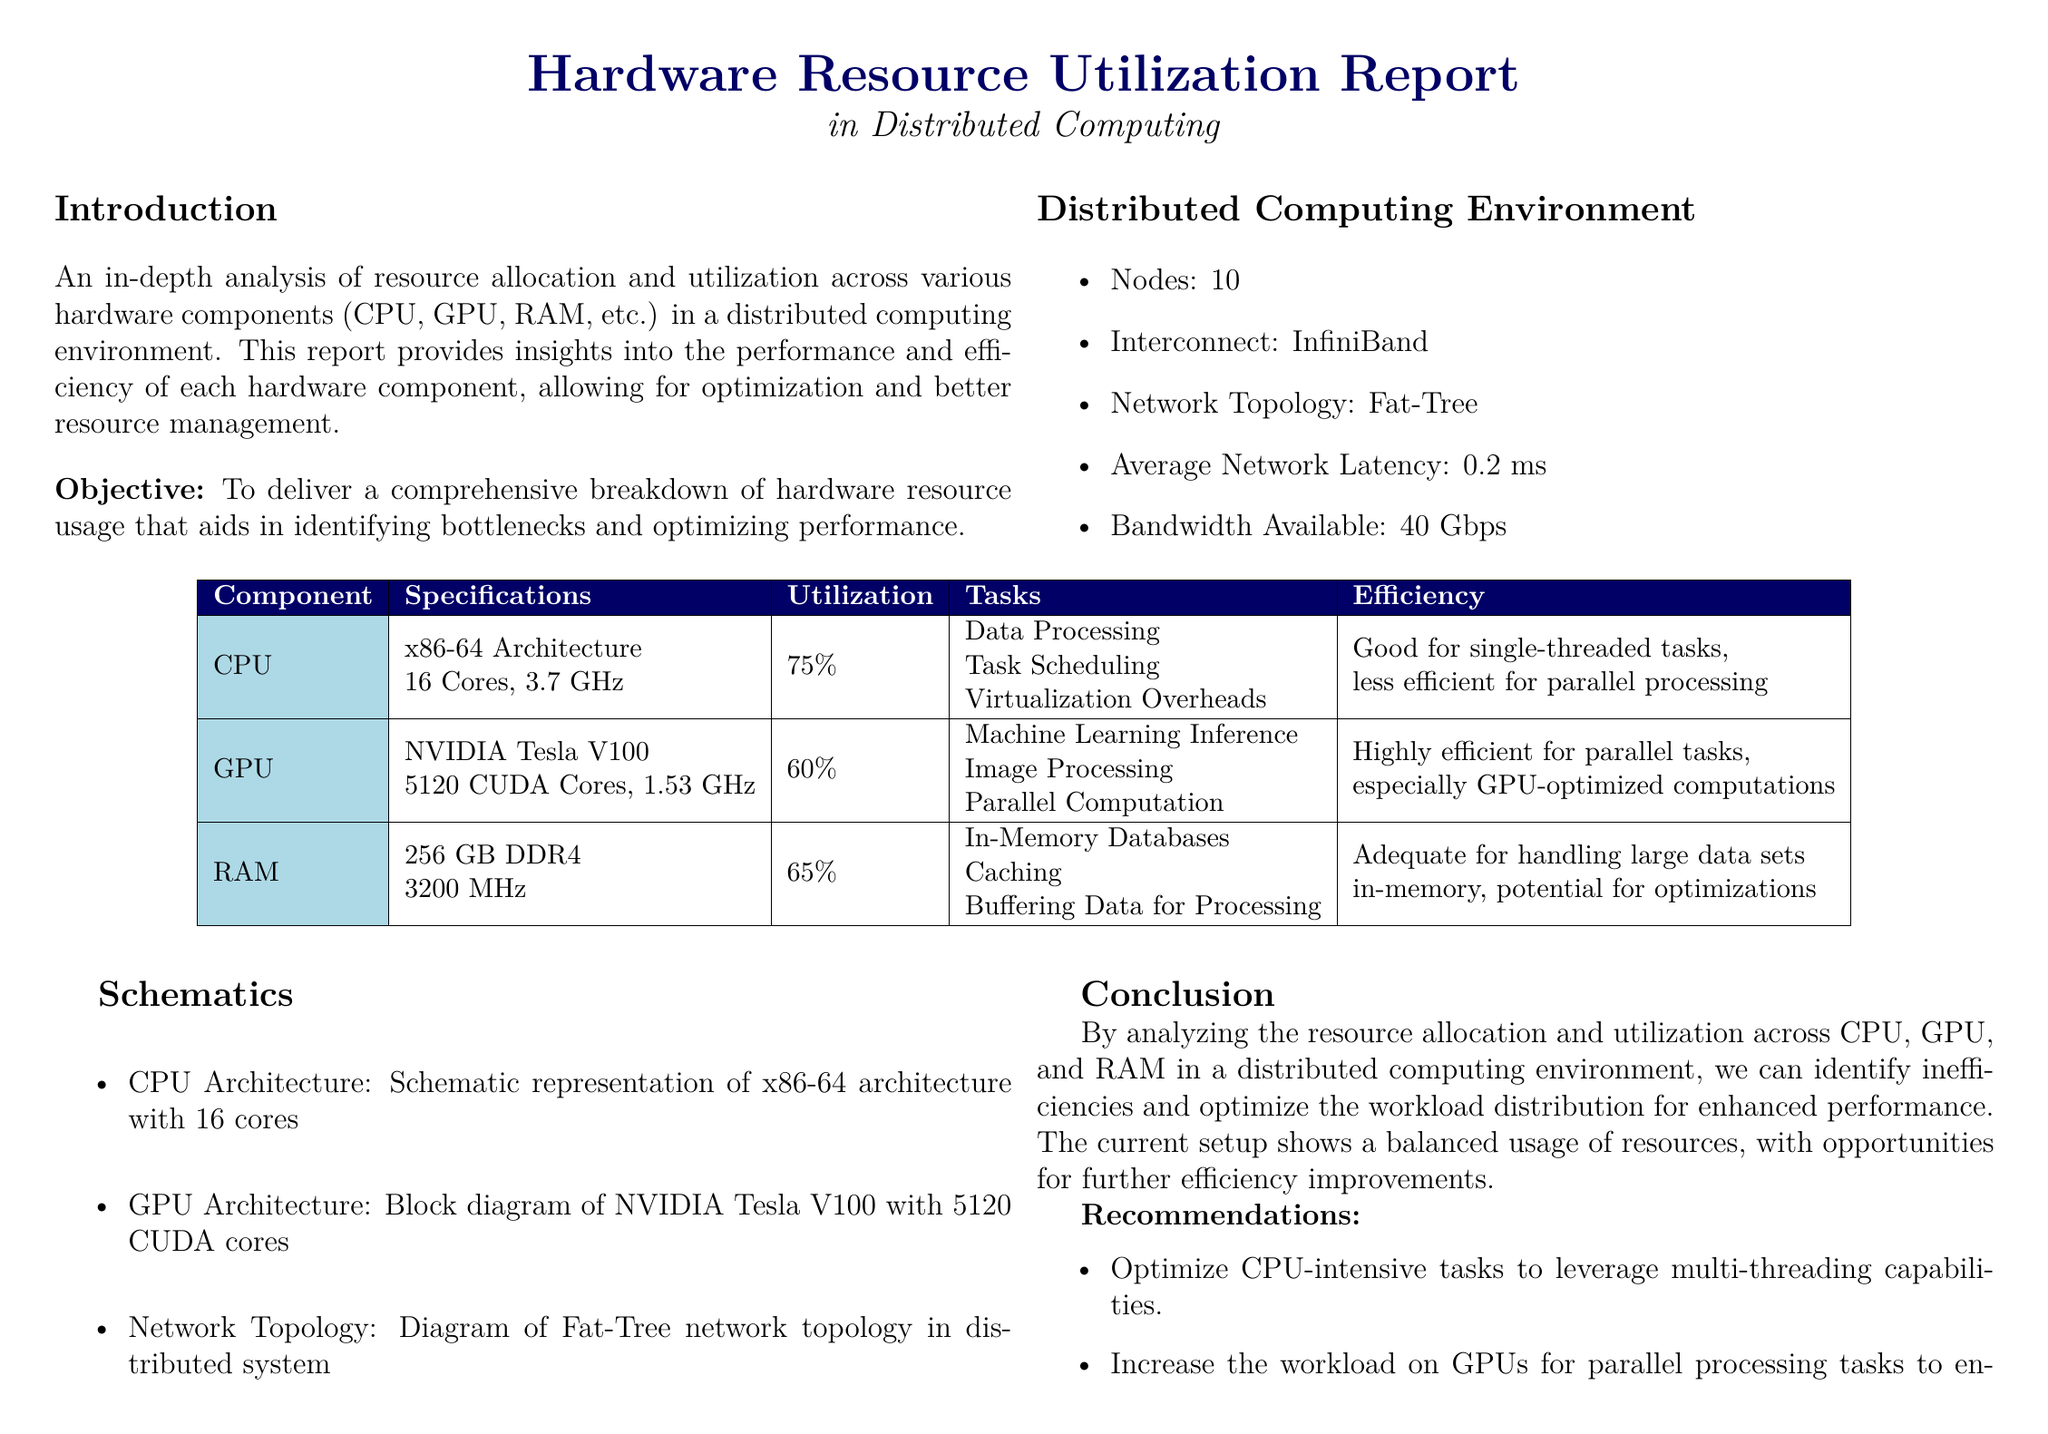What is the number of nodes in the distributed computing environment? The document states that there are 10 nodes in the distributed computing environment.
Answer: 10 What is the average network latency? The report mentions that the average network latency is 0.2 ms.
Answer: 0.2 ms What is the GPU model used in this setup? The document specifies that the GPU model used is NVIDIA Tesla V100.
Answer: NVIDIA Tesla V100 What is the RAM specification provided in the report? The report outlines that the RAM is 256 GB DDR4 with a speed of 3200 MHz.
Answer: 256 GB DDR4, 3200 MHz How efficient is the CPU for parallel processing tasks? The document states that the CPU is less efficient for parallel processing.
Answer: Less efficient What is the bandwidth available in the distributed computing environment? The report indicates that the bandwidth available is 40 Gbps.
Answer: 40 Gbps Which hardware component has the highest utilization percentage? According to the document, the CPU has the highest utilization at 75%.
Answer: 75% What is the recommended improvement for CPU-intensive tasks? The report recommends optimizing CPU-intensive tasks to leverage multi-threading capabilities.
Answer: Multi-threading capabilities How many CUDA cores does the GPU have? The document specifies that the NVIDIA Tesla V100 has 5120 CUDA cores.
Answer: 5120 CUDA cores 